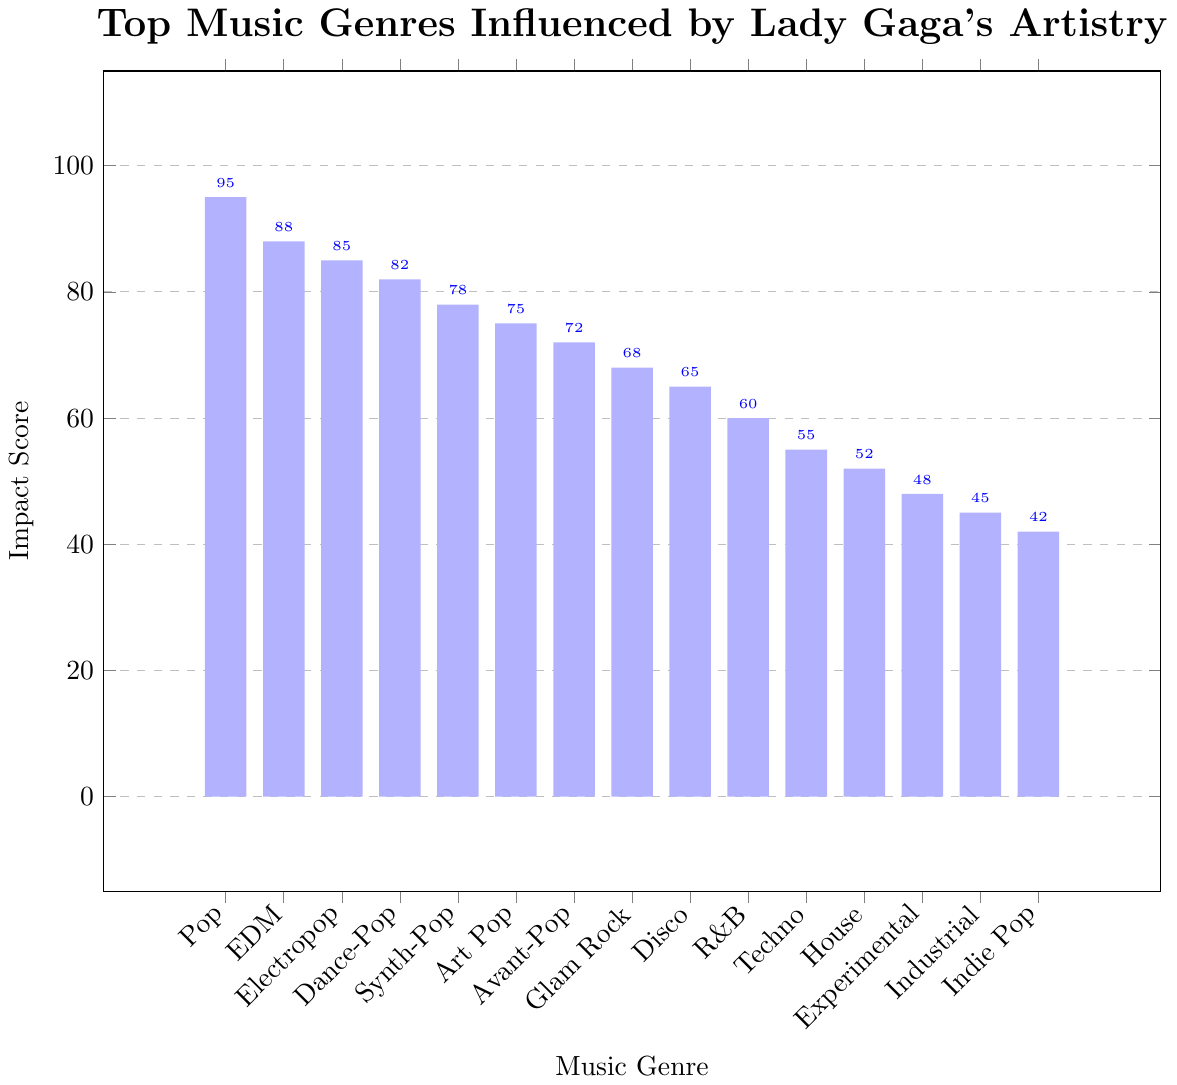Which genre has the highest impact score? The genre with the highest bar represents the highest impact score. The highest bar belongs to the Pop genre.
Answer: Pop Which two genres have the closest impact scores? Compare the heights of the bars to find the closest two. The Disco (65) and R&B (60) bars are close together.
Answer: Disco and R&B Which genre has a higher impact score, Glam Rock or Art Pop? Look at the heights of the Glam Rock and Art Pop bars. The Art Pop bar is taller at 75, while the Glam Rock bar is at 68.
Answer: Art Pop What is the average impact score of the top 5 genres? Sum the impact scores of the top 5 genres: (Pop, EDM, Electropop, Dance-Pop, Synth-Pop). Calculate (95 + 88 + 85 + 82 + 78) / 5.
Answer: 85.6 How much higher is the Impact Score of EDM compared to House? Subtract the impact score of House from EDM. The impact score for EDM is 88 and House is 52. Calculate 88 - 52.
Answer: 36 Which genre has an impact score just below Synth-Pop? Find the genre with one score below Synth-Pop's score of 78. The next lower bar belongs to Art Pop with a score of 75.
Answer: Art Pop What is the total impact score of all the genres shown? Sum the impact scores of all the genres: (95 + 88 + 85 + 82 + 78 + 75 + 72 + 68 + 65 + 60 + 55 + 52 + 48 + 45 + 42).
Answer: 1000 How many genres have an impact score of 70 or above? Count the bars with height 70 or higher. These bars belong to Pop, EDM, Electropop, Dance-Pop, Synth-Pop, Art Pop, and Avant-Pop.
Answer: 7 Which genres have impact scores between 50 and 70 inclusive? Identify the genres within this range: R&B (60), Techno (55), and House (52).
Answer: R&B, Techno, and House What is the difference between the highest and lowest impact scores? Subtract the lowest score from the highest. The lowest is 42 (Indie Pop) and the highest is 95 (Pop). Calculate 95 - 42.
Answer: 53 